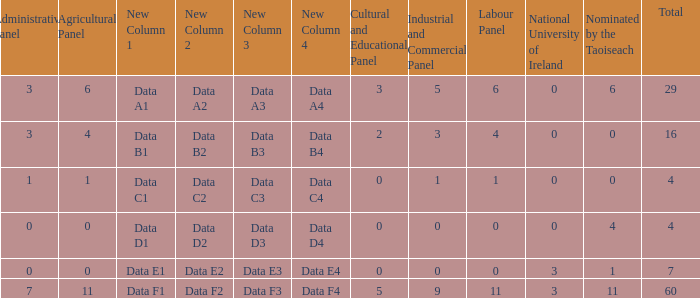What is the average nominated of the composition nominated by Taioseach with an Industrial and Commercial panel less than 9, an administrative panel greater than 0, a cultural and educational panel greater than 2, and a total less than 29? None. 